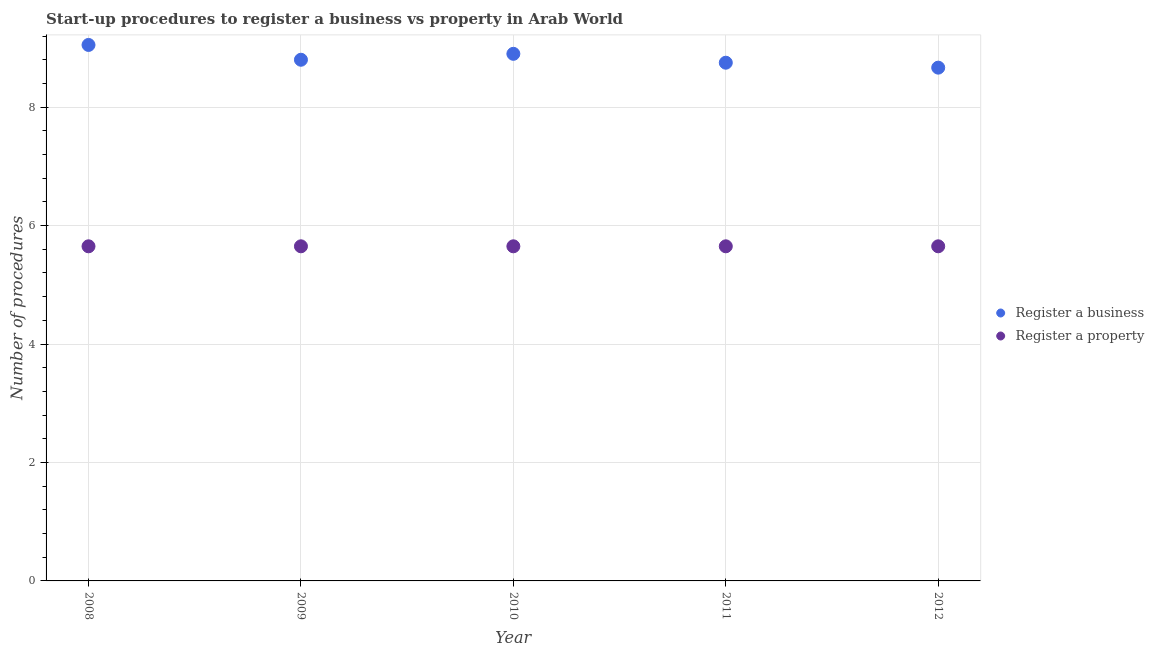How many different coloured dotlines are there?
Your answer should be very brief. 2. Is the number of dotlines equal to the number of legend labels?
Offer a terse response. Yes. What is the number of procedures to register a property in 2009?
Keep it short and to the point. 5.65. Across all years, what is the maximum number of procedures to register a business?
Give a very brief answer. 9.05. Across all years, what is the minimum number of procedures to register a property?
Keep it short and to the point. 5.65. In which year was the number of procedures to register a property maximum?
Provide a short and direct response. 2008. What is the total number of procedures to register a property in the graph?
Make the answer very short. 28.25. What is the difference between the number of procedures to register a property in 2011 and that in 2012?
Provide a succinct answer. 0. What is the average number of procedures to register a business per year?
Offer a very short reply. 8.83. In the year 2012, what is the difference between the number of procedures to register a business and number of procedures to register a property?
Keep it short and to the point. 3.02. In how many years, is the number of procedures to register a property greater than 4?
Make the answer very short. 5. What is the ratio of the number of procedures to register a business in 2009 to that in 2010?
Offer a very short reply. 0.99. Is the number of procedures to register a business in 2009 less than that in 2010?
Give a very brief answer. Yes. What is the difference between the highest and the second highest number of procedures to register a business?
Provide a succinct answer. 0.15. What is the difference between the highest and the lowest number of procedures to register a business?
Provide a short and direct response. 0.38. Is the number of procedures to register a property strictly less than the number of procedures to register a business over the years?
Your answer should be very brief. Yes. How many years are there in the graph?
Offer a terse response. 5. Are the values on the major ticks of Y-axis written in scientific E-notation?
Your response must be concise. No. Does the graph contain grids?
Give a very brief answer. Yes. Where does the legend appear in the graph?
Give a very brief answer. Center right. How many legend labels are there?
Give a very brief answer. 2. What is the title of the graph?
Your response must be concise. Start-up procedures to register a business vs property in Arab World. Does "Formally registered" appear as one of the legend labels in the graph?
Ensure brevity in your answer.  No. What is the label or title of the Y-axis?
Provide a short and direct response. Number of procedures. What is the Number of procedures in Register a business in 2008?
Ensure brevity in your answer.  9.05. What is the Number of procedures in Register a property in 2008?
Your answer should be very brief. 5.65. What is the Number of procedures of Register a business in 2009?
Offer a terse response. 8.8. What is the Number of procedures in Register a property in 2009?
Give a very brief answer. 5.65. What is the Number of procedures of Register a property in 2010?
Give a very brief answer. 5.65. What is the Number of procedures of Register a business in 2011?
Offer a terse response. 8.75. What is the Number of procedures in Register a property in 2011?
Provide a succinct answer. 5.65. What is the Number of procedures of Register a business in 2012?
Offer a terse response. 8.67. What is the Number of procedures of Register a property in 2012?
Give a very brief answer. 5.65. Across all years, what is the maximum Number of procedures of Register a business?
Give a very brief answer. 9.05. Across all years, what is the maximum Number of procedures of Register a property?
Give a very brief answer. 5.65. Across all years, what is the minimum Number of procedures of Register a business?
Provide a succinct answer. 8.67. Across all years, what is the minimum Number of procedures of Register a property?
Keep it short and to the point. 5.65. What is the total Number of procedures in Register a business in the graph?
Your answer should be very brief. 44.17. What is the total Number of procedures of Register a property in the graph?
Provide a succinct answer. 28.25. What is the difference between the Number of procedures of Register a property in 2008 and that in 2009?
Offer a very short reply. 0. What is the difference between the Number of procedures in Register a business in 2008 and that in 2010?
Your answer should be compact. 0.15. What is the difference between the Number of procedures in Register a property in 2008 and that in 2011?
Keep it short and to the point. 0. What is the difference between the Number of procedures of Register a business in 2008 and that in 2012?
Give a very brief answer. 0.38. What is the difference between the Number of procedures of Register a property in 2008 and that in 2012?
Provide a short and direct response. 0. What is the difference between the Number of procedures in Register a property in 2009 and that in 2010?
Give a very brief answer. 0. What is the difference between the Number of procedures in Register a business in 2009 and that in 2011?
Give a very brief answer. 0.05. What is the difference between the Number of procedures in Register a business in 2009 and that in 2012?
Make the answer very short. 0.13. What is the difference between the Number of procedures in Register a business in 2010 and that in 2011?
Your answer should be compact. 0.15. What is the difference between the Number of procedures of Register a business in 2010 and that in 2012?
Keep it short and to the point. 0.23. What is the difference between the Number of procedures of Register a business in 2011 and that in 2012?
Your response must be concise. 0.08. What is the difference between the Number of procedures of Register a business in 2008 and the Number of procedures of Register a property in 2009?
Ensure brevity in your answer.  3.4. What is the difference between the Number of procedures in Register a business in 2009 and the Number of procedures in Register a property in 2010?
Your response must be concise. 3.15. What is the difference between the Number of procedures in Register a business in 2009 and the Number of procedures in Register a property in 2011?
Your response must be concise. 3.15. What is the difference between the Number of procedures of Register a business in 2009 and the Number of procedures of Register a property in 2012?
Keep it short and to the point. 3.15. What is the difference between the Number of procedures in Register a business in 2010 and the Number of procedures in Register a property in 2012?
Provide a succinct answer. 3.25. What is the difference between the Number of procedures of Register a business in 2011 and the Number of procedures of Register a property in 2012?
Give a very brief answer. 3.1. What is the average Number of procedures of Register a business per year?
Your response must be concise. 8.83. What is the average Number of procedures of Register a property per year?
Ensure brevity in your answer.  5.65. In the year 2008, what is the difference between the Number of procedures of Register a business and Number of procedures of Register a property?
Give a very brief answer. 3.4. In the year 2009, what is the difference between the Number of procedures in Register a business and Number of procedures in Register a property?
Your answer should be compact. 3.15. In the year 2010, what is the difference between the Number of procedures of Register a business and Number of procedures of Register a property?
Keep it short and to the point. 3.25. In the year 2012, what is the difference between the Number of procedures in Register a business and Number of procedures in Register a property?
Your response must be concise. 3.02. What is the ratio of the Number of procedures of Register a business in 2008 to that in 2009?
Provide a short and direct response. 1.03. What is the ratio of the Number of procedures in Register a property in 2008 to that in 2009?
Offer a terse response. 1. What is the ratio of the Number of procedures of Register a business in 2008 to that in 2010?
Your answer should be compact. 1.02. What is the ratio of the Number of procedures in Register a property in 2008 to that in 2010?
Provide a succinct answer. 1. What is the ratio of the Number of procedures of Register a business in 2008 to that in 2011?
Keep it short and to the point. 1.03. What is the ratio of the Number of procedures of Register a business in 2008 to that in 2012?
Make the answer very short. 1.04. What is the ratio of the Number of procedures of Register a property in 2009 to that in 2010?
Make the answer very short. 1. What is the ratio of the Number of procedures of Register a property in 2009 to that in 2011?
Offer a terse response. 1. What is the ratio of the Number of procedures in Register a business in 2009 to that in 2012?
Provide a short and direct response. 1.02. What is the ratio of the Number of procedures of Register a business in 2010 to that in 2011?
Your answer should be compact. 1.02. What is the ratio of the Number of procedures in Register a property in 2010 to that in 2011?
Make the answer very short. 1. What is the ratio of the Number of procedures in Register a business in 2010 to that in 2012?
Give a very brief answer. 1.03. What is the ratio of the Number of procedures in Register a property in 2010 to that in 2012?
Your answer should be very brief. 1. What is the ratio of the Number of procedures of Register a business in 2011 to that in 2012?
Make the answer very short. 1.01. What is the ratio of the Number of procedures in Register a property in 2011 to that in 2012?
Give a very brief answer. 1. What is the difference between the highest and the second highest Number of procedures in Register a property?
Make the answer very short. 0. What is the difference between the highest and the lowest Number of procedures in Register a business?
Offer a very short reply. 0.38. 